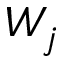Convert formula to latex. <formula><loc_0><loc_0><loc_500><loc_500>W _ { j }</formula> 